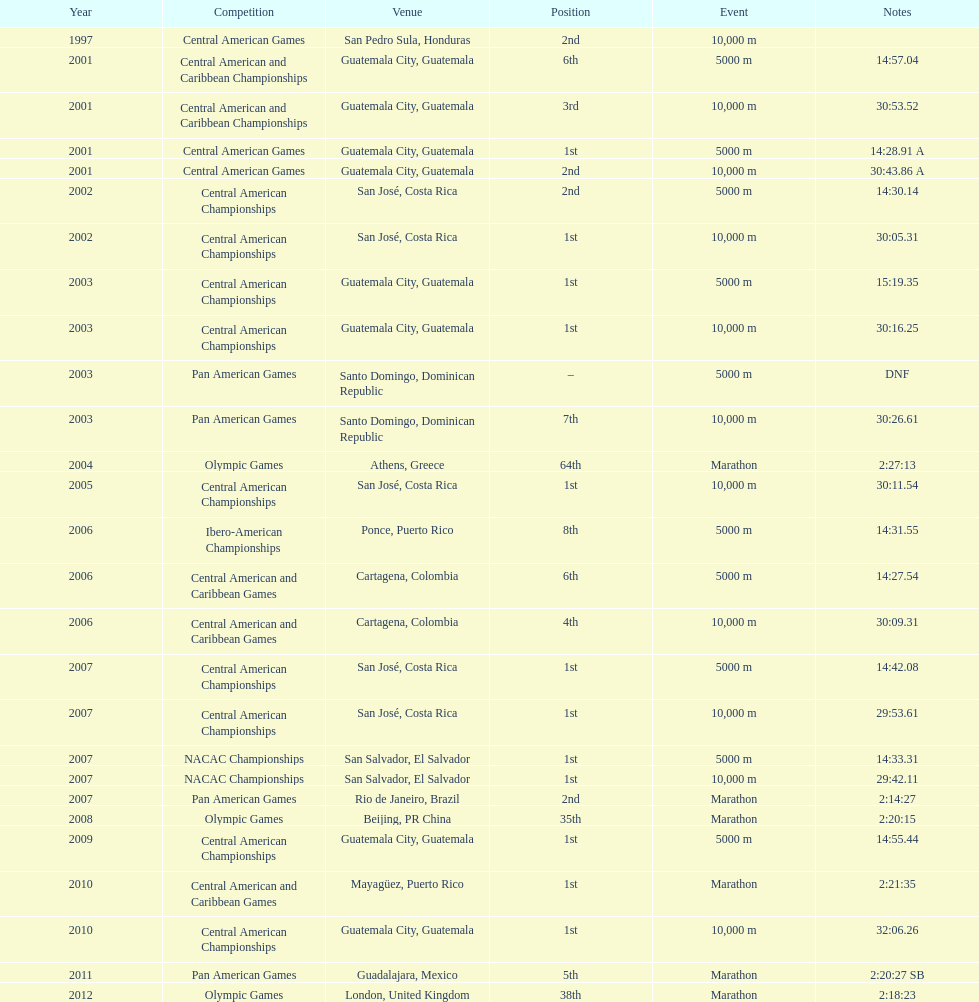The central american championships and what other competition occurred in 2010? Central American and Caribbean Games. Can you give me this table as a dict? {'header': ['Year', 'Competition', 'Venue', 'Position', 'Event', 'Notes'], 'rows': [['1997', 'Central American Games', 'San Pedro Sula, Honduras', '2nd', '10,000 m', ''], ['2001', 'Central American and Caribbean Championships', 'Guatemala City, Guatemala', '6th', '5000 m', '14:57.04'], ['2001', 'Central American and Caribbean Championships', 'Guatemala City, Guatemala', '3rd', '10,000 m', '30:53.52'], ['2001', 'Central American Games', 'Guatemala City, Guatemala', '1st', '5000 m', '14:28.91 A'], ['2001', 'Central American Games', 'Guatemala City, Guatemala', '2nd', '10,000 m', '30:43.86 A'], ['2002', 'Central American Championships', 'San José, Costa Rica', '2nd', '5000 m', '14:30.14'], ['2002', 'Central American Championships', 'San José, Costa Rica', '1st', '10,000 m', '30:05.31'], ['2003', 'Central American Championships', 'Guatemala City, Guatemala', '1st', '5000 m', '15:19.35'], ['2003', 'Central American Championships', 'Guatemala City, Guatemala', '1st', '10,000 m', '30:16.25'], ['2003', 'Pan American Games', 'Santo Domingo, Dominican Republic', '–', '5000 m', 'DNF'], ['2003', 'Pan American Games', 'Santo Domingo, Dominican Republic', '7th', '10,000 m', '30:26.61'], ['2004', 'Olympic Games', 'Athens, Greece', '64th', 'Marathon', '2:27:13'], ['2005', 'Central American Championships', 'San José, Costa Rica', '1st', '10,000 m', '30:11.54'], ['2006', 'Ibero-American Championships', 'Ponce, Puerto Rico', '8th', '5000 m', '14:31.55'], ['2006', 'Central American and Caribbean Games', 'Cartagena, Colombia', '6th', '5000 m', '14:27.54'], ['2006', 'Central American and Caribbean Games', 'Cartagena, Colombia', '4th', '10,000 m', '30:09.31'], ['2007', 'Central American Championships', 'San José, Costa Rica', '1st', '5000 m', '14:42.08'], ['2007', 'Central American Championships', 'San José, Costa Rica', '1st', '10,000 m', '29:53.61'], ['2007', 'NACAC Championships', 'San Salvador, El Salvador', '1st', '5000 m', '14:33.31'], ['2007', 'NACAC Championships', 'San Salvador, El Salvador', '1st', '10,000 m', '29:42.11'], ['2007', 'Pan American Games', 'Rio de Janeiro, Brazil', '2nd', 'Marathon', '2:14:27'], ['2008', 'Olympic Games', 'Beijing, PR China', '35th', 'Marathon', '2:20:15'], ['2009', 'Central American Championships', 'Guatemala City, Guatemala', '1st', '5000 m', '14:55.44'], ['2010', 'Central American and Caribbean Games', 'Mayagüez, Puerto Rico', '1st', 'Marathon', '2:21:35'], ['2010', 'Central American Championships', 'Guatemala City, Guatemala', '1st', '10,000 m', '32:06.26'], ['2011', 'Pan American Games', 'Guadalajara, Mexico', '5th', 'Marathon', '2:20:27 SB'], ['2012', 'Olympic Games', 'London, United Kingdom', '38th', 'Marathon', '2:18:23']]} 